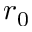Convert formula to latex. <formula><loc_0><loc_0><loc_500><loc_500>r _ { 0 }</formula> 